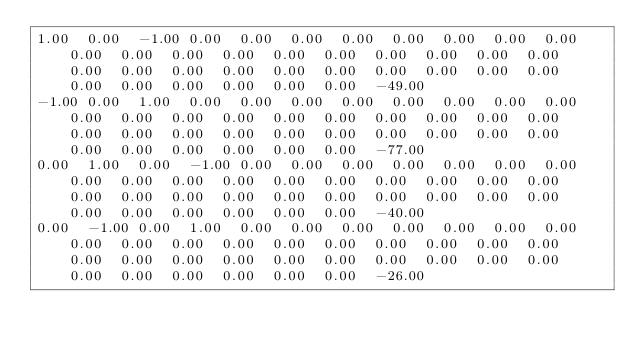Convert code to text. <code><loc_0><loc_0><loc_500><loc_500><_Matlab_>1.00	0.00	-1.00	0.00	0.00	0.00	0.00	0.00	0.00	0.00	0.00	0.00	0.00	0.00	0.00	0.00	0.00	0.00	0.00	0.00	0.00	0.00	0.00	0.00	0.00	0.00	0.00	0.00	0.00	0.00	0.00	0.00	0.00	0.00	0.00	0.00	0.00	-49.00
-1.00	0.00	1.00	0.00	0.00	0.00	0.00	0.00	0.00	0.00	0.00	0.00	0.00	0.00	0.00	0.00	0.00	0.00	0.00	0.00	0.00	0.00	0.00	0.00	0.00	0.00	0.00	0.00	0.00	0.00	0.00	0.00	0.00	0.00	0.00	0.00	0.00	-77.00
0.00	1.00	0.00	-1.00	0.00	0.00	0.00	0.00	0.00	0.00	0.00	0.00	0.00	0.00	0.00	0.00	0.00	0.00	0.00	0.00	0.00	0.00	0.00	0.00	0.00	0.00	0.00	0.00	0.00	0.00	0.00	0.00	0.00	0.00	0.00	0.00	0.00	-40.00
0.00	-1.00	0.00	1.00	0.00	0.00	0.00	0.00	0.00	0.00	0.00	0.00	0.00	0.00	0.00	0.00	0.00	0.00	0.00	0.00	0.00	0.00	0.00	0.00	0.00	0.00	0.00	0.00	0.00	0.00	0.00	0.00	0.00	0.00	0.00	0.00	0.00	-26.00
</code> 